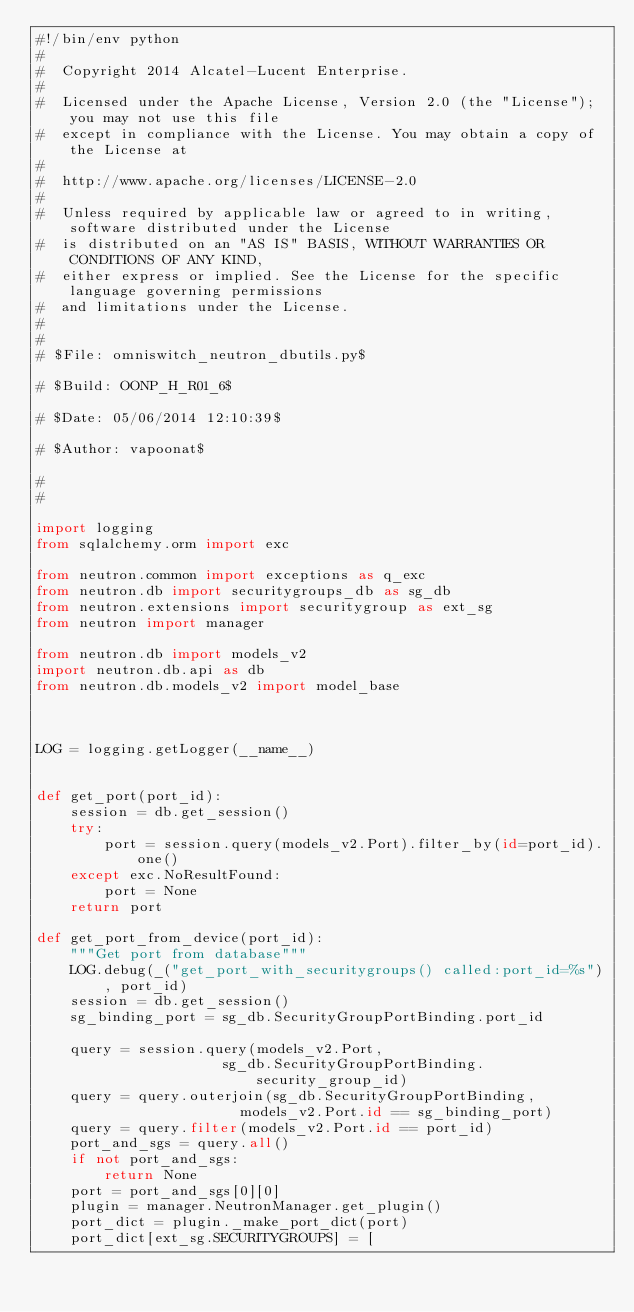Convert code to text. <code><loc_0><loc_0><loc_500><loc_500><_Python_>#!/bin/env python
#
#  Copyright 2014 Alcatel-Lucent Enterprise.
#
#  Licensed under the Apache License, Version 2.0 (the "License"); you may not use this file
#  except in compliance with the License. You may obtain a copy of the License at
#
#  http://www.apache.org/licenses/LICENSE-2.0
#
#  Unless required by applicable law or agreed to in writing, software distributed under the License
#  is distributed on an "AS IS" BASIS, WITHOUT WARRANTIES OR CONDITIONS OF ANY KIND,
#  either express or implied. See the License for the specific language governing permissions
#  and limitations under the License.
#
#
# $File: omniswitch_neutron_dbutils.py$

# $Build: OONP_H_R01_6$

# $Date: 05/06/2014 12:10:39$

# $Author: vapoonat$

#
#

import logging
from sqlalchemy.orm import exc

from neutron.common import exceptions as q_exc
from neutron.db import securitygroups_db as sg_db
from neutron.extensions import securitygroup as ext_sg
from neutron import manager

from neutron.db import models_v2
import neutron.db.api as db
from neutron.db.models_v2 import model_base



LOG = logging.getLogger(__name__)


def get_port(port_id):
    session = db.get_session()
    try:
        port = session.query(models_v2.Port).filter_by(id=port_id).one()
    except exc.NoResultFound:
        port = None
    return port

def get_port_from_device(port_id):
    """Get port from database"""
    LOG.debug(_("get_port_with_securitygroups() called:port_id=%s"), port_id)
    session = db.get_session()
    sg_binding_port = sg_db.SecurityGroupPortBinding.port_id

    query = session.query(models_v2.Port,
                      sg_db.SecurityGroupPortBinding.security_group_id)
    query = query.outerjoin(sg_db.SecurityGroupPortBinding,
                        models_v2.Port.id == sg_binding_port)
    query = query.filter(models_v2.Port.id == port_id)
    port_and_sgs = query.all()
    if not port_and_sgs:
        return None
    port = port_and_sgs[0][0]
    plugin = manager.NeutronManager.get_plugin()
    port_dict = plugin._make_port_dict(port)
    port_dict[ext_sg.SECURITYGROUPS] = [</code> 